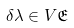Convert formula to latex. <formula><loc_0><loc_0><loc_500><loc_500>\delta \lambda \in V { \mathfrak { E } }</formula> 